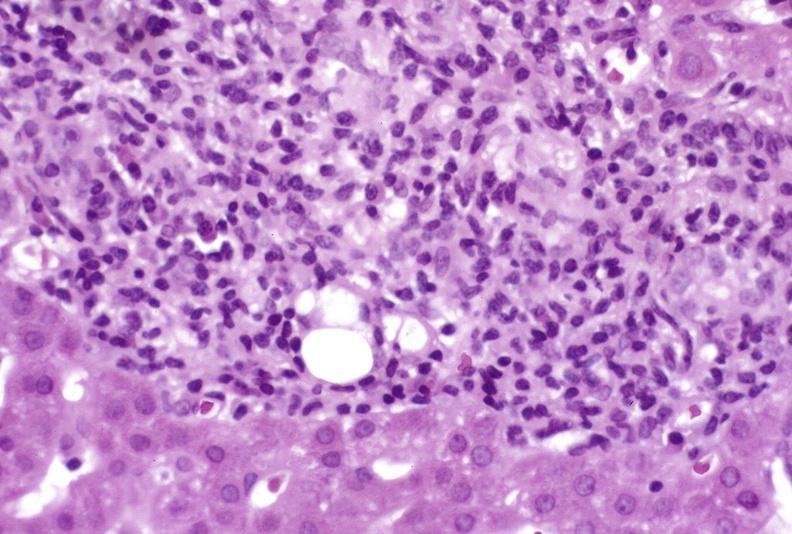what is present?
Answer the question using a single word or phrase. Liver 